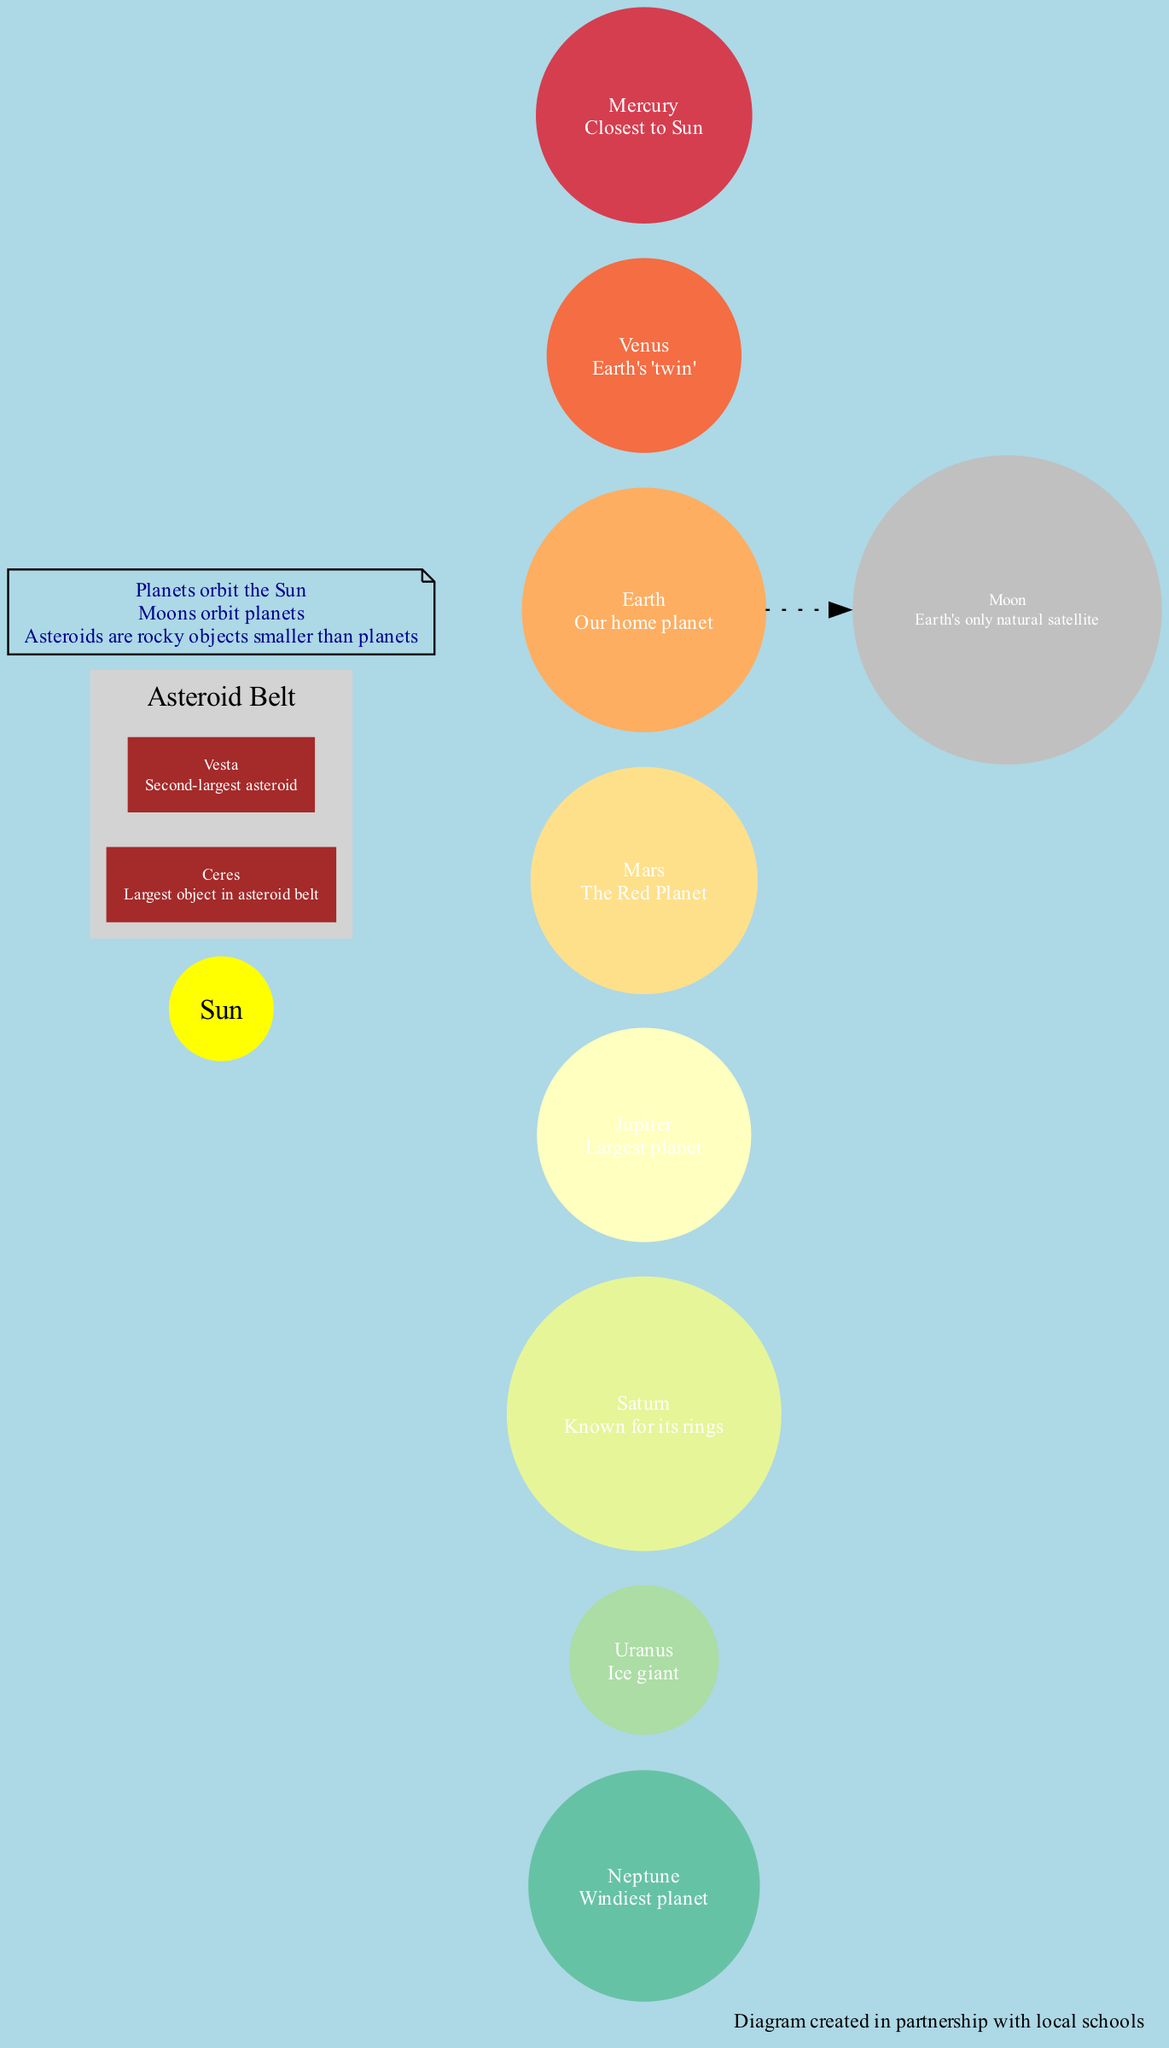What is the largest planet in the solar system? The diagram labels Jupiter as the largest planet, indicating its position among the other planets.
Answer: Jupiter How many planets are shown in the diagram? By counting the nodes representing the planets in the diagram, we find a total of eight planets listed.
Answer: 8 Which planet is known as the Windiest planet? Neptune is labeled as the Windiest planet, which is mentioned directly next to Neptune's node in the diagram.
Answer: Neptune What is Earth's only natural satellite called? The diagram specifies that Moon is Earth's only natural satellite, providing a clear relationship between Earth and its moon.
Answer: Moon What is the label given to Venus in the diagram? The label for Venus in the diagram is "Earth's 'twin'," which is indicated prominently next to the planet's node.
Answer: Earth's 'twin' How many asteroids are depicted in the asteroid belt section of the diagram? The subgraph for asteroids lists two specific asteroids, Ceres and Vesta, so adding these gives us the number of asteroids shown.
Answer: 2 What color are the planets represented in the diagram? Each planet is represented in a different spectral color as per the color code given, but all are filled with colors from the spectral palette.
Answer: Spectral colors Which planet has a moon? The only planet mentioned with a moon in the diagram is Earth, which is specified next to the Earth node.
Answer: Earth What is the largest object in the asteroid belt? Ceres is labeled as the largest object in the asteroid belt, which is noted near the Ceres node within the asteroid cluster.
Answer: Ceres 